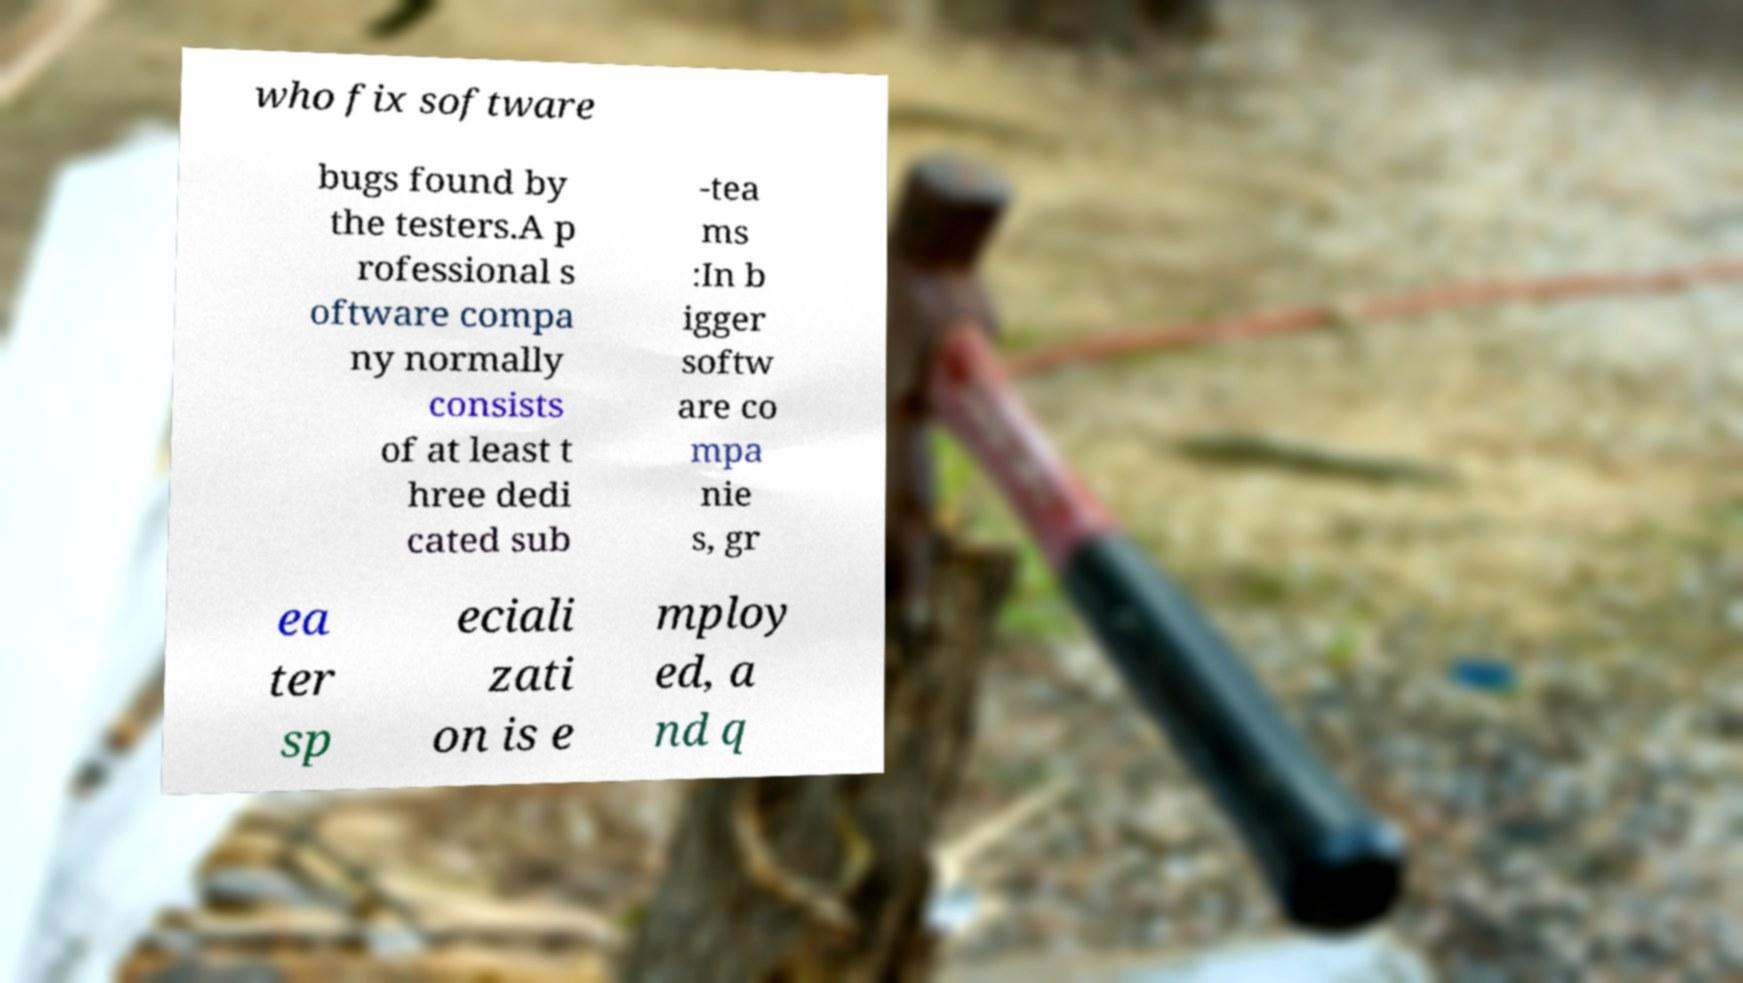There's text embedded in this image that I need extracted. Can you transcribe it verbatim? who fix software bugs found by the testers.A p rofessional s oftware compa ny normally consists of at least t hree dedi cated sub -tea ms :In b igger softw are co mpa nie s, gr ea ter sp eciali zati on is e mploy ed, a nd q 